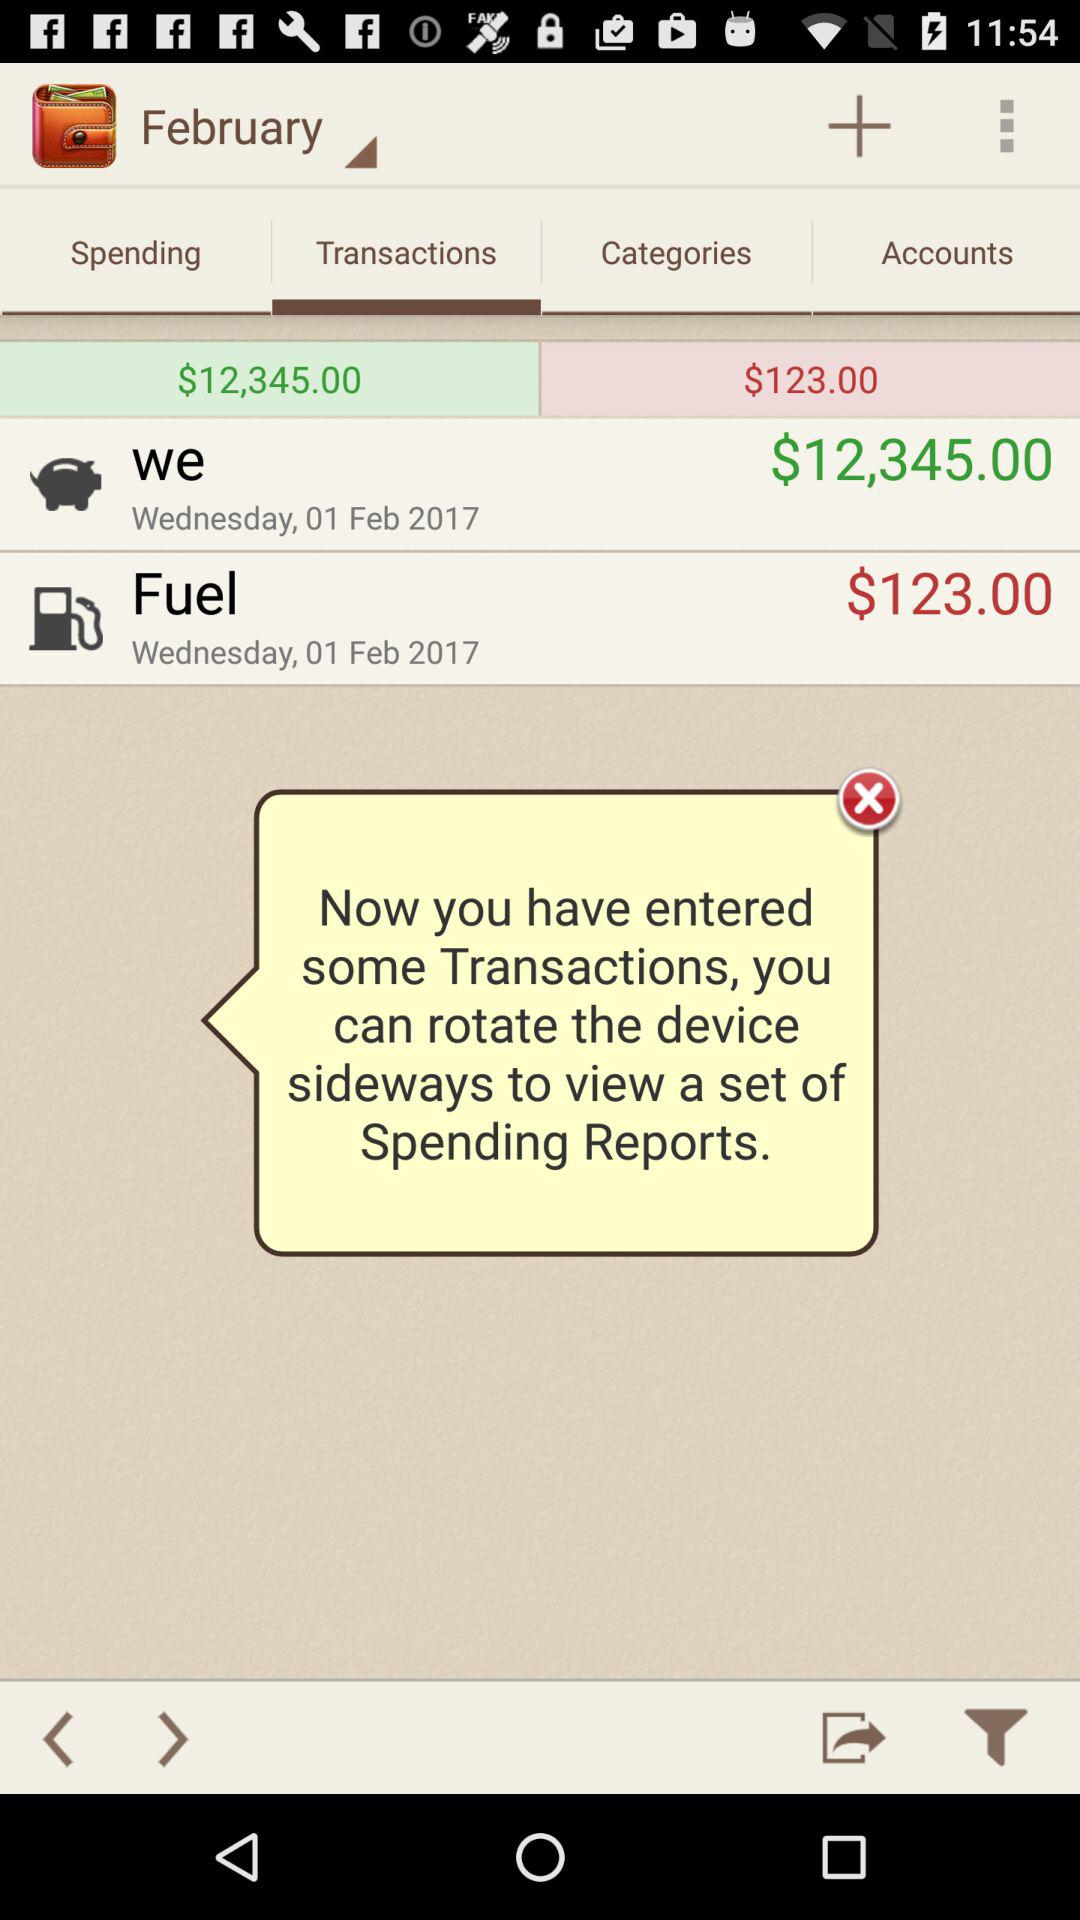How much amount was credited on February 1, 2017? The credited amount is $12,345.00. 